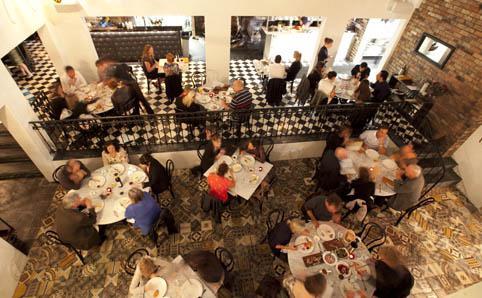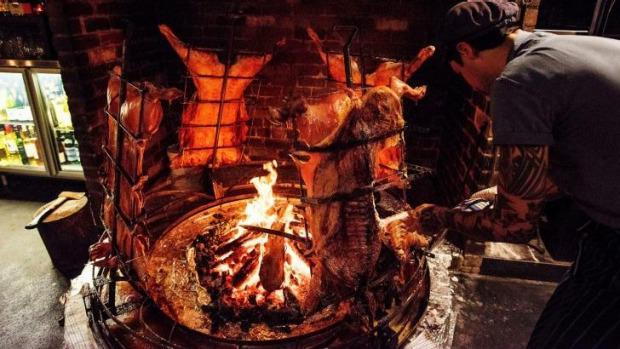The first image is the image on the left, the second image is the image on the right. Given the left and right images, does the statement "They are roasting pigs in one of the images." hold true? Answer yes or no. Yes. The first image is the image on the left, the second image is the image on the right. For the images displayed, is the sentence "There are pigs surrounding a fire pit." factually correct? Answer yes or no. Yes. 